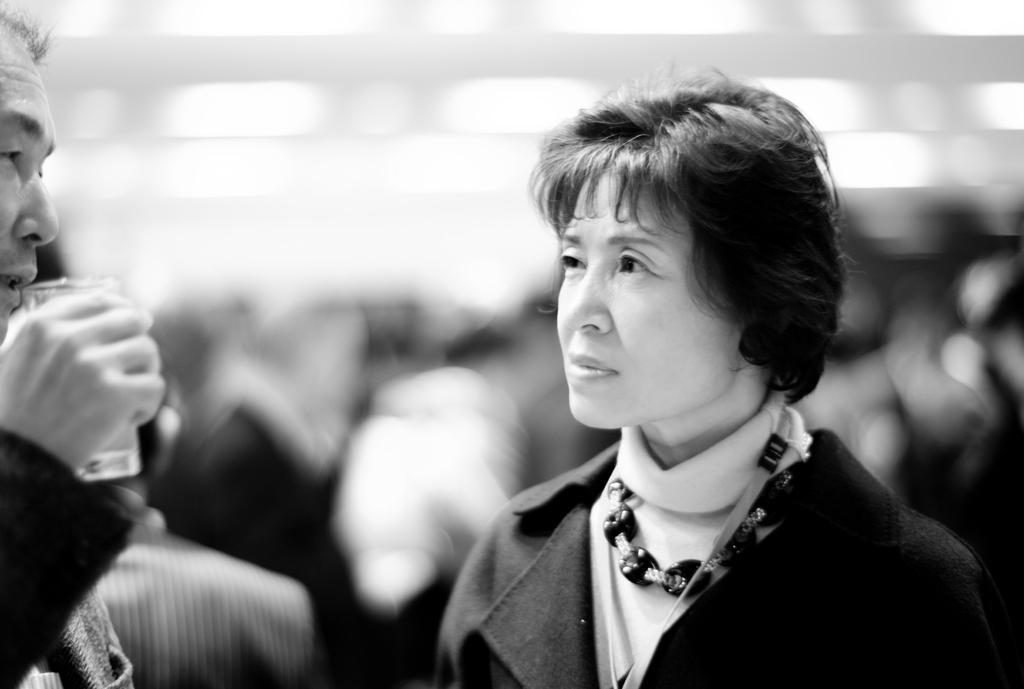Please provide a concise description of this image. It is a black and white image. In this image people are standing are standing on the floor. 